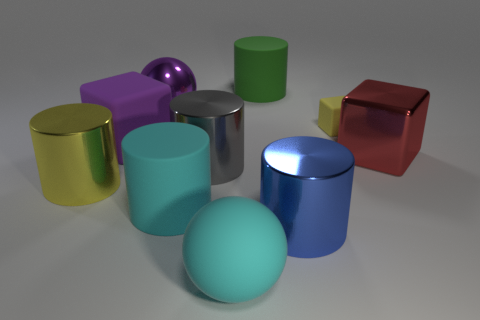Are there an equal number of large yellow cylinders to the right of the yellow cylinder and red cubes that are behind the tiny yellow thing?
Your answer should be compact. Yes. Are there any tiny yellow rubber objects in front of the large rubber cylinder that is in front of the big cube to the left of the blue object?
Keep it short and to the point. No. Do the purple ball and the blue metallic object have the same size?
Provide a short and direct response. Yes. There is a cylinder on the left side of the purple cube in front of the matte cylinder that is behind the big gray metal thing; what is its color?
Offer a terse response. Yellow. How many balls have the same color as the large matte cube?
Provide a short and direct response. 1. How many small objects are cyan blocks or cyan matte balls?
Provide a succinct answer. 0. Is there a big gray shiny thing that has the same shape as the large red object?
Offer a very short reply. No. Does the big yellow thing have the same shape as the gray metallic thing?
Offer a very short reply. Yes. The big block that is to the left of the green object that is to the left of the large blue cylinder is what color?
Provide a succinct answer. Purple. The rubber sphere that is the same size as the red thing is what color?
Ensure brevity in your answer.  Cyan. 